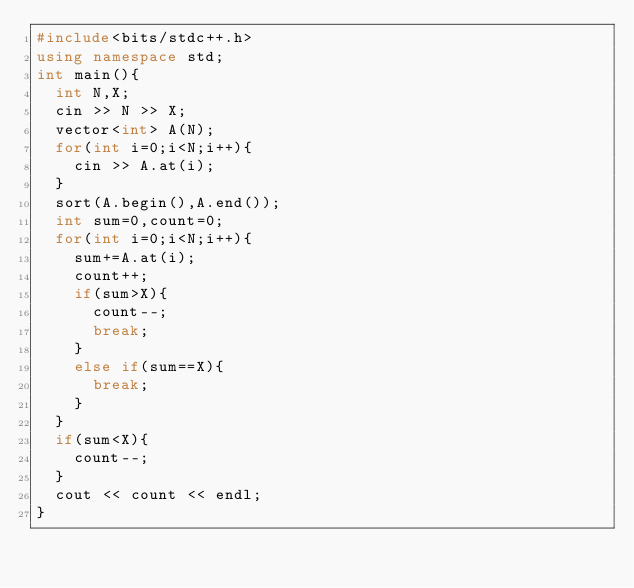<code> <loc_0><loc_0><loc_500><loc_500><_C++_>#include<bits/stdc++.h>
using namespace std;
int main(){
  int N,X;
  cin >> N >> X;
  vector<int> A(N);
  for(int i=0;i<N;i++){
    cin >> A.at(i);
  }
  sort(A.begin(),A.end());
  int sum=0,count=0;
  for(int i=0;i<N;i++){
    sum+=A.at(i);
    count++;
    if(sum>X){
      count--;
      break;
    }
    else if(sum==X){
      break;
    }
  }
  if(sum<X){
    count--;
  }
  cout << count << endl;
}
</code> 